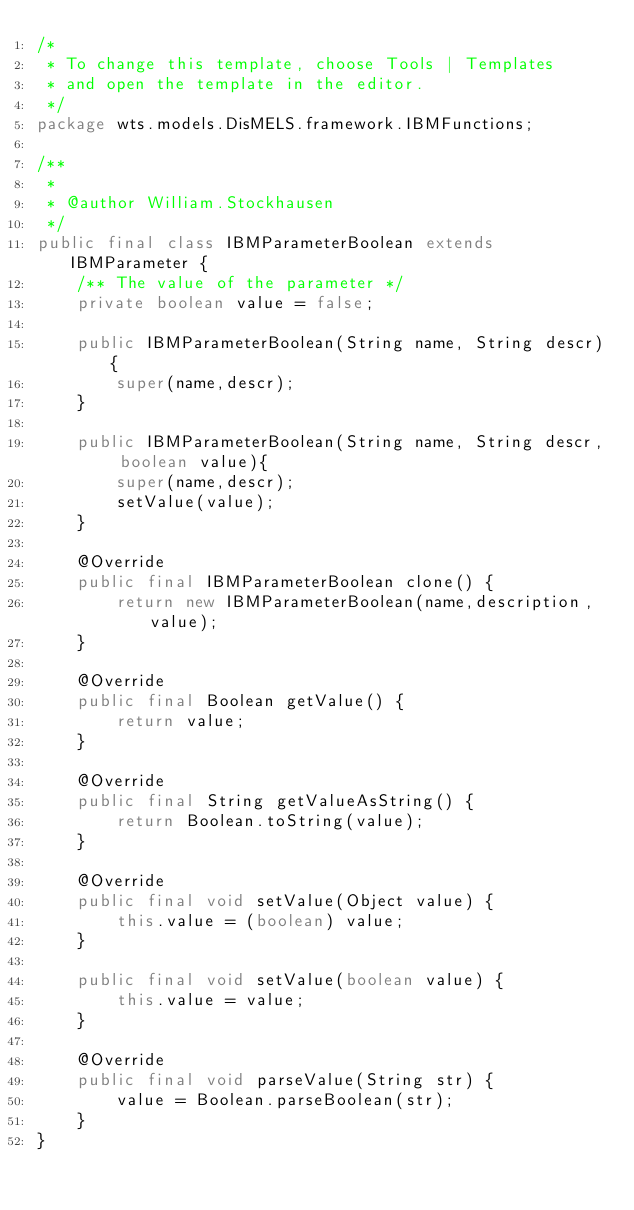Convert code to text. <code><loc_0><loc_0><loc_500><loc_500><_Java_>/*
 * To change this template, choose Tools | Templates
 * and open the template in the editor.
 */
package wts.models.DisMELS.framework.IBMFunctions;

/**
 *
 * @author William.Stockhausen
 */
public final class IBMParameterBoolean extends IBMParameter {
    /** The value of the parameter */
    private boolean value = false;
    
    public IBMParameterBoolean(String name, String descr){
        super(name,descr);
    }

    public IBMParameterBoolean(String name, String descr, boolean value){
        super(name,descr);
        setValue(value);
    }

    @Override
    public final IBMParameterBoolean clone() {
        return new IBMParameterBoolean(name,description,value);
    }

    @Override
    public final Boolean getValue() {
        return value;
    }

    @Override
    public final String getValueAsString() {
        return Boolean.toString(value);
    }

    @Override
    public final void setValue(Object value) {
        this.value = (boolean) value;
    }

    public final void setValue(boolean value) {
        this.value = value;
    }

    @Override
    public final void parseValue(String str) {
        value = Boolean.parseBoolean(str);
    }
}
</code> 